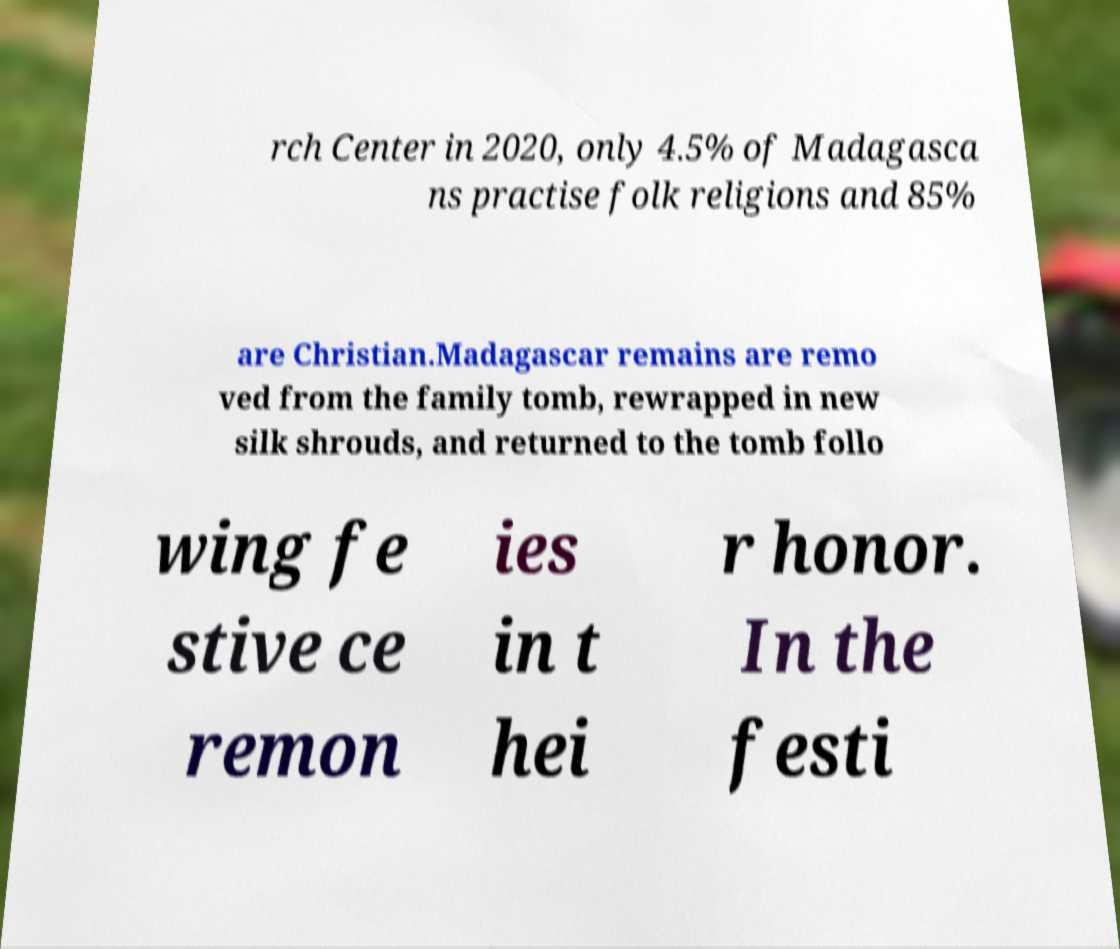For documentation purposes, I need the text within this image transcribed. Could you provide that? rch Center in 2020, only 4.5% of Madagasca ns practise folk religions and 85% are Christian.Madagascar remains are remo ved from the family tomb, rewrapped in new silk shrouds, and returned to the tomb follo wing fe stive ce remon ies in t hei r honor. In the festi 